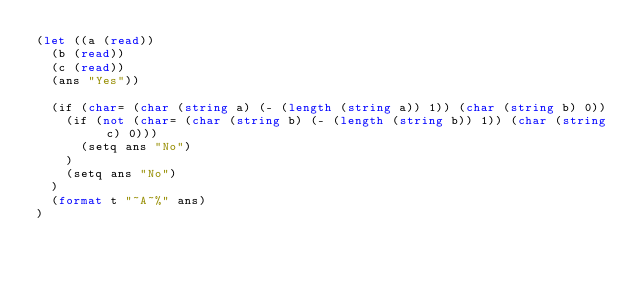Convert code to text. <code><loc_0><loc_0><loc_500><loc_500><_Lisp_>(let ((a (read))
	(b (read))
	(c (read))
	(ans "Yes"))
	
	(if (char= (char (string a) (- (length (string a)) 1)) (char (string b) 0))
		(if (not (char= (char (string b) (- (length (string b)) 1)) (char (string c) 0)))
			(setq ans "No")
		)
		(setq ans "No")
	)
	(format t "~A~%" ans)
)</code> 